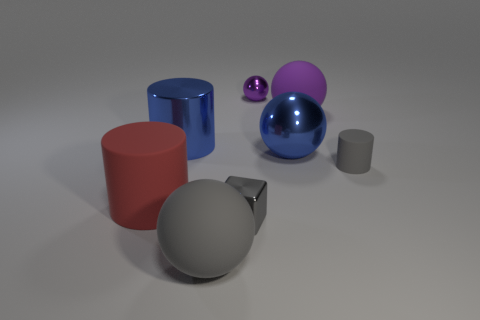Subtract all purple cylinders. How many purple spheres are left? 2 Subtract 2 spheres. How many spheres are left? 2 Subtract all large cylinders. How many cylinders are left? 1 Subtract all gray spheres. How many spheres are left? 3 Add 2 big green matte cubes. How many objects exist? 10 Subtract all yellow balls. Subtract all green blocks. How many balls are left? 4 Subtract all cylinders. How many objects are left? 5 Add 3 big gray objects. How many big gray objects are left? 4 Add 5 gray cubes. How many gray cubes exist? 6 Subtract 0 cyan spheres. How many objects are left? 8 